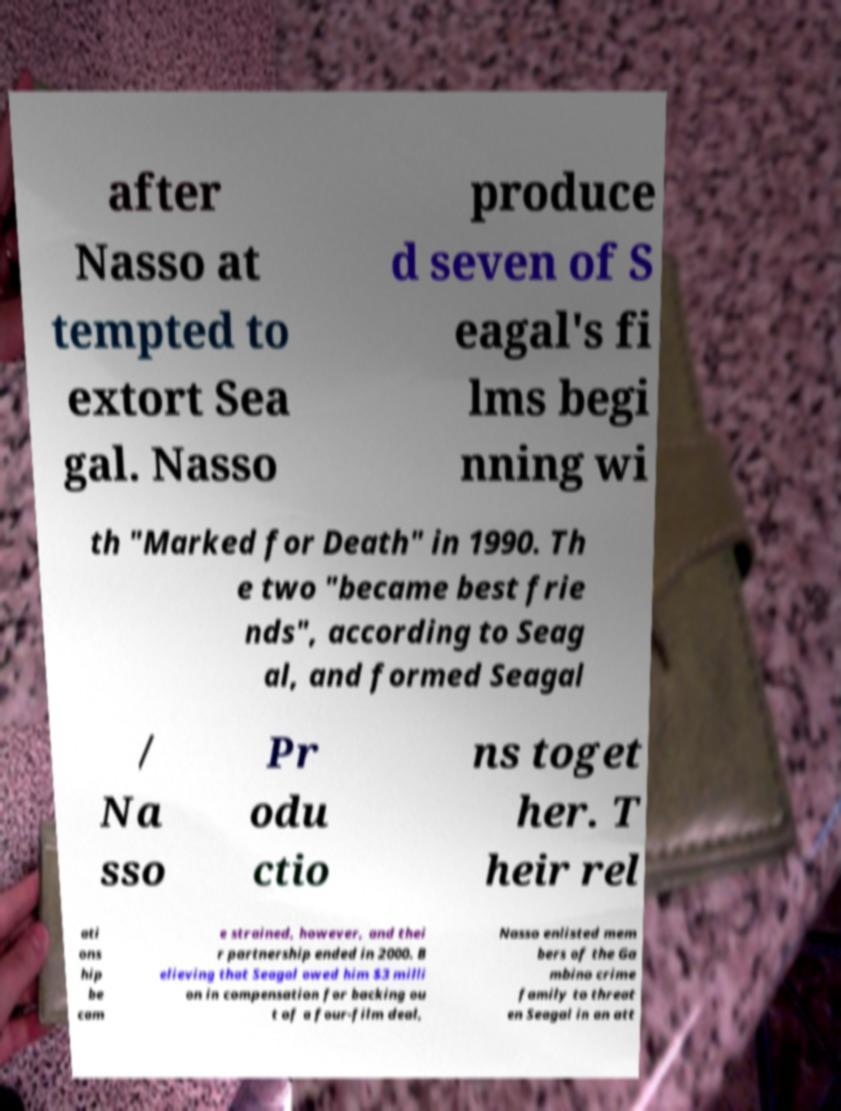Can you read and provide the text displayed in the image?This photo seems to have some interesting text. Can you extract and type it out for me? after Nasso at tempted to extort Sea gal. Nasso produce d seven of S eagal's fi lms begi nning wi th "Marked for Death" in 1990. Th e two "became best frie nds", according to Seag al, and formed Seagal / Na sso Pr odu ctio ns toget her. T heir rel ati ons hip be cam e strained, however, and thei r partnership ended in 2000. B elieving that Seagal owed him $3 milli on in compensation for backing ou t of a four-film deal, Nasso enlisted mem bers of the Ga mbino crime family to threat en Seagal in an att 